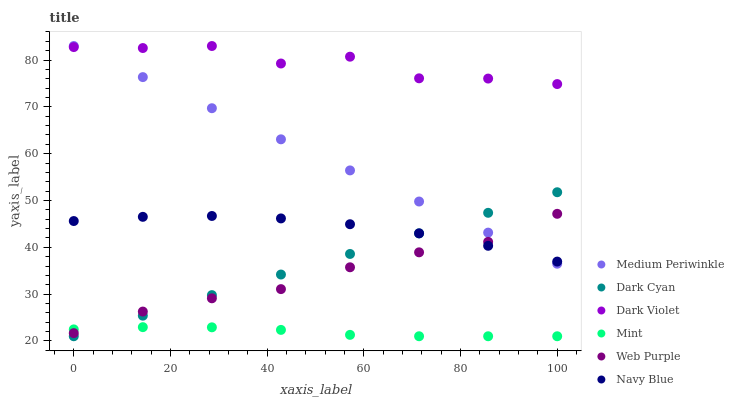Does Mint have the minimum area under the curve?
Answer yes or no. Yes. Does Dark Violet have the maximum area under the curve?
Answer yes or no. Yes. Does Medium Periwinkle have the minimum area under the curve?
Answer yes or no. No. Does Medium Periwinkle have the maximum area under the curve?
Answer yes or no. No. Is Dark Cyan the smoothest?
Answer yes or no. Yes. Is Dark Violet the roughest?
Answer yes or no. Yes. Is Medium Periwinkle the smoothest?
Answer yes or no. No. Is Medium Periwinkle the roughest?
Answer yes or no. No. Does Dark Cyan have the lowest value?
Answer yes or no. Yes. Does Medium Periwinkle have the lowest value?
Answer yes or no. No. Does Dark Violet have the highest value?
Answer yes or no. Yes. Does Web Purple have the highest value?
Answer yes or no. No. Is Mint less than Navy Blue?
Answer yes or no. Yes. Is Dark Violet greater than Mint?
Answer yes or no. Yes. Does Dark Violet intersect Medium Periwinkle?
Answer yes or no. Yes. Is Dark Violet less than Medium Periwinkle?
Answer yes or no. No. Is Dark Violet greater than Medium Periwinkle?
Answer yes or no. No. Does Mint intersect Navy Blue?
Answer yes or no. No. 